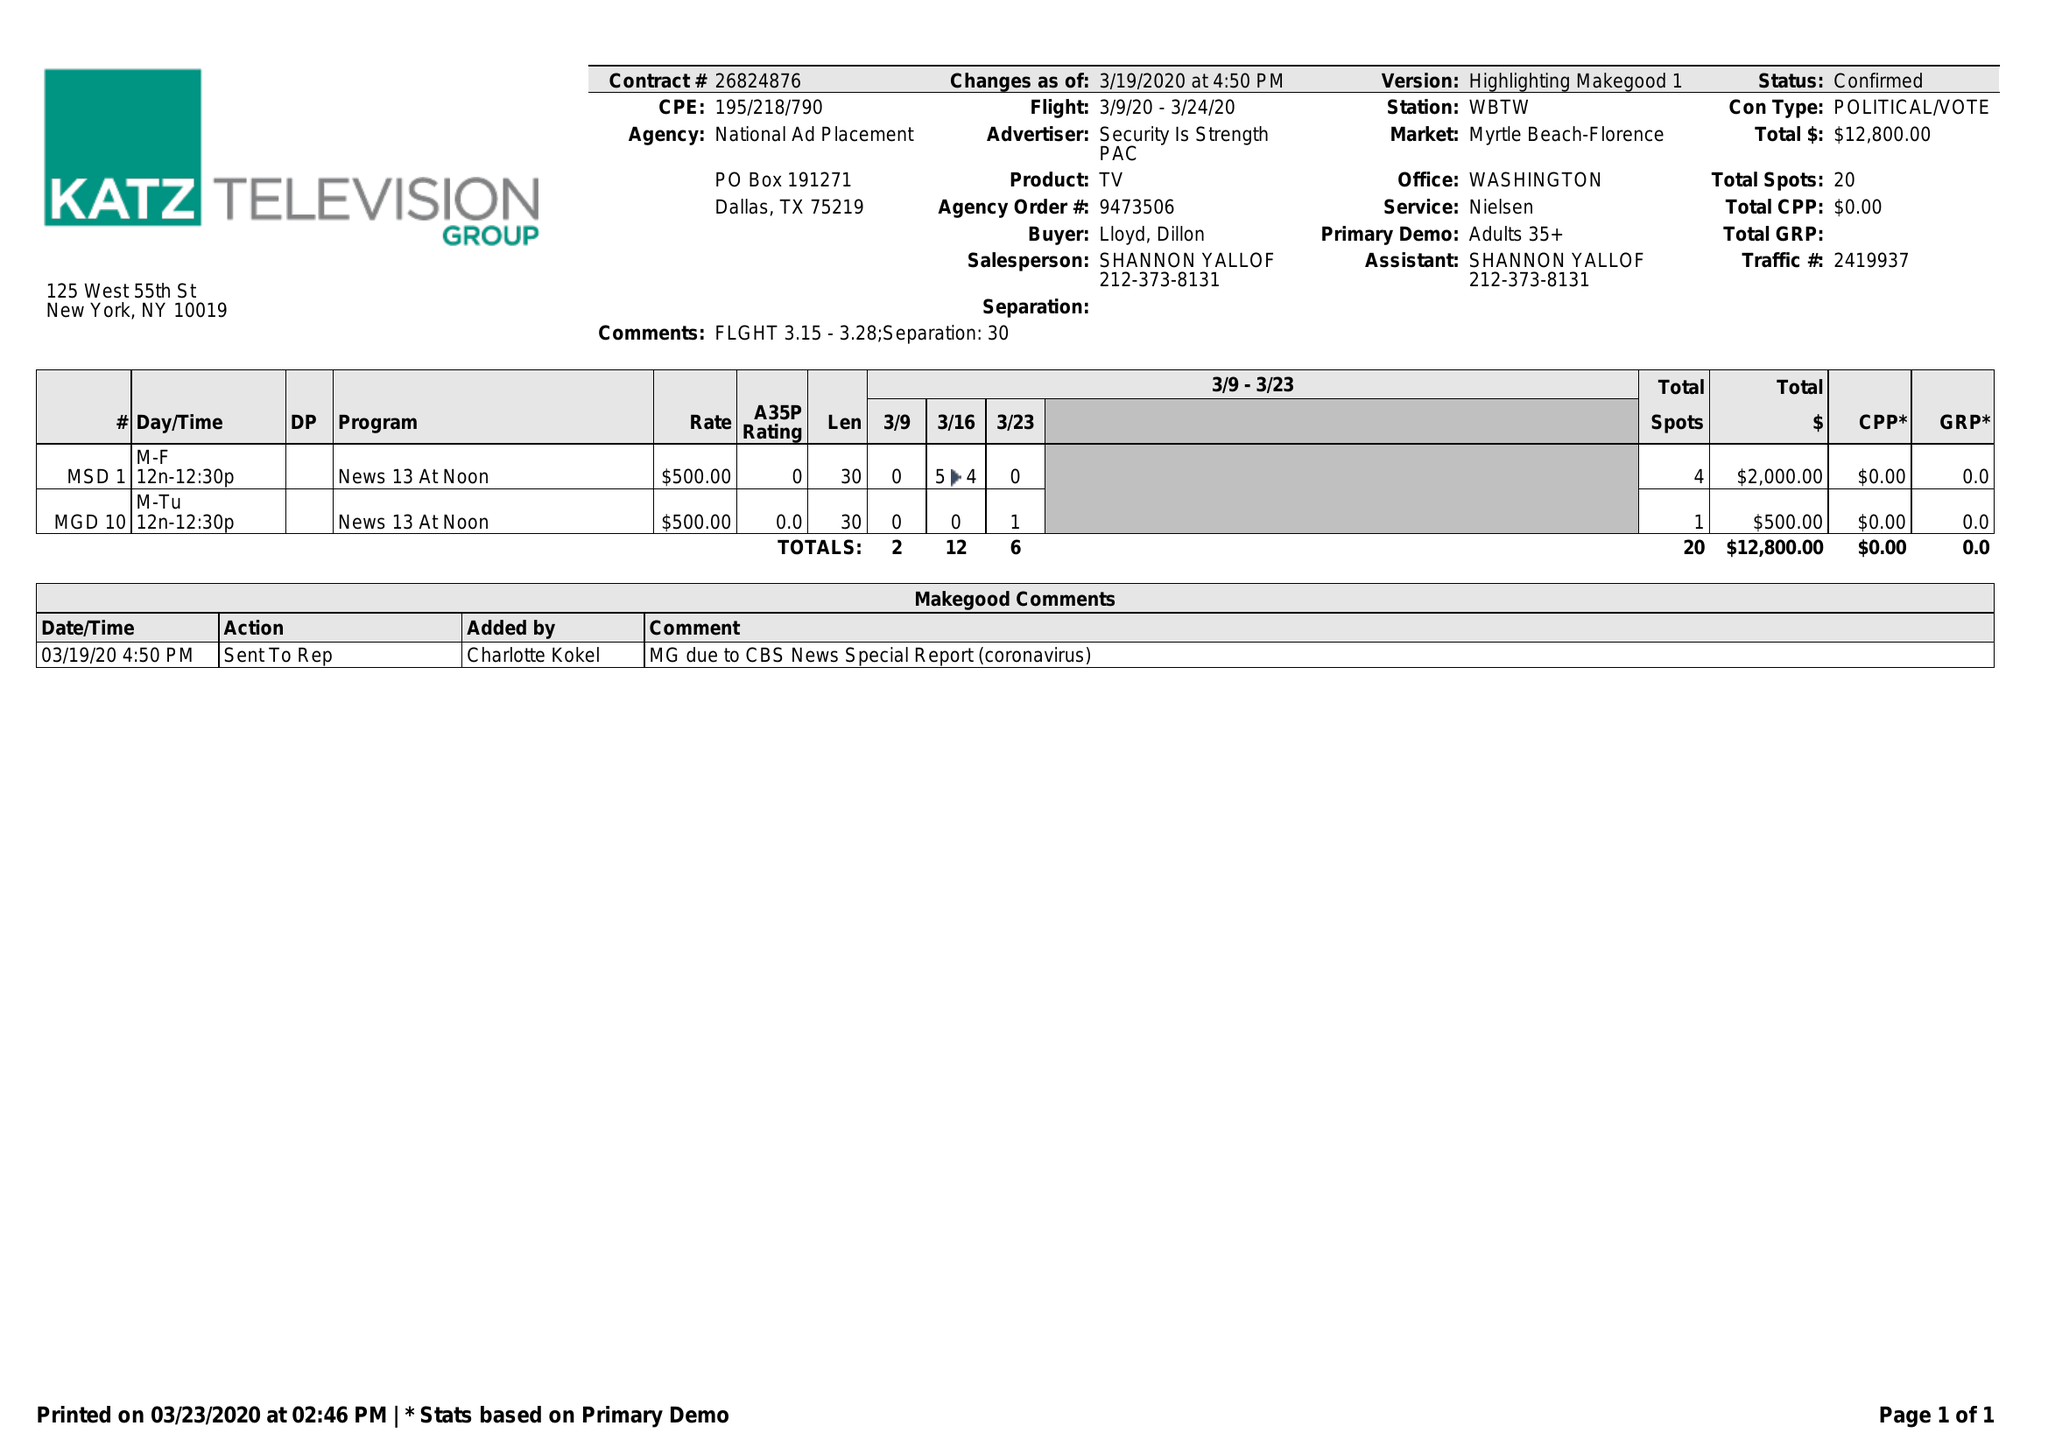What is the value for the flight_from?
Answer the question using a single word or phrase. 03/09/20 